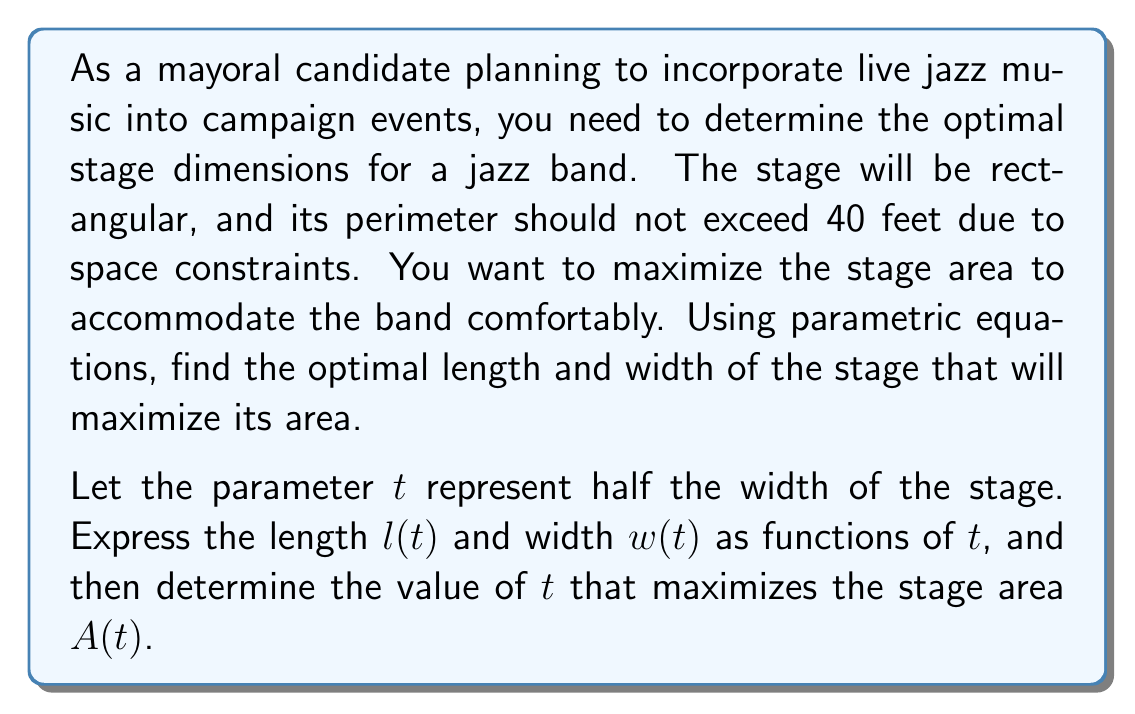Help me with this question. Let's approach this problem step-by-step:

1) First, we need to express the length and width in terms of the parameter $t$:
   
   Width: $w(t) = 2t$
   Length: $l(t) = 20 - t$ (since the perimeter is 40, and $2l + 2w = 40$)

2) The area function $A(t)$ can be expressed as:

   $A(t) = l(t) \cdot w(t) = (20-t)(2t) = 40t - 2t^2$

3) To find the maximum area, we need to find the value of $t$ where $\frac{dA}{dt} = 0$:

   $\frac{dA}{dt} = 40 - 4t$

4) Setting this equal to zero:

   $40 - 4t = 0$
   $4t = 40$
   $t = 10$

5) To confirm this is a maximum, we can check the second derivative:

   $\frac{d^2A}{dt^2} = -4$, which is negative, confirming a maximum.

6) Now that we know $t = 10$ maximizes the area, we can calculate the optimal dimensions:

   Width: $w(10) = 2(10) = 20$ feet
   Length: $l(10) = 20 - 10 = 10$ feet

7) The maximum area is:

   $A(10) = 40(10) - 2(10)^2 = 400 - 200 = 200$ square feet
Answer: The optimal stage dimensions for the jazz band are 20 feet wide and 10 feet long, providing a maximum area of 200 square feet. 